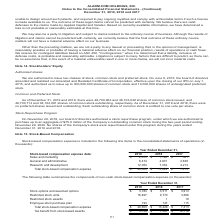According to Alarmcom Holdings's financial document, What was the value of restricted stock units in 2019?? According to the financial document, 16,627 (in thousands). The relevant text states: "ns $ 3,783 $ 3,511 $ 3,913 Restricted stock units 16,627 9,770 3,366 Restricted stock awards — 1 19 Employee stock purchase plan 193 147 115 Total stock-bas..." Also, What was the Stock options and assumed options in 2018? According to the financial document, 3,511 (in thousands). The relevant text states: "2017 Stock options and assumed options $ 3,783 $ 3,511 $ 3,913 Restricted stock units 16,627 9,770 3,366 Restricted stock awards — 1 19 Employee stock pur..." Also, Which years does the table provide information for  the components of non-cash stock-based compensation expense for? The document contains multiple relevant values: 2019, 2018, 2017. From the document: "Stock-based compensation expense data: 2019 2018 2017 Sales and marketing $ 2,075 $ 1,196 $ 561 General and administrative 6,474 4,901 2,638 Research ..." Also, How many years did Stock options and assumed options exceed $3,000 thousand? Counting the relevant items in the document: 2019, 2018, 2017, I find 3 instances. The key data points involved are: 2017, 2018, 2019. Also, can you calculate: What was the change in the Employee stock purchase plan between 2018 and 2019? Based on the calculation: 193-147, the result is 46 (in thousands). This is based on the information: "stock awards — 1 19 Employee stock purchase plan 193 147 115 Total stock-based compensation expense $ 20,603 $ 13,429 $ 7,413 Tax benefit from stock-bas ck awards — 1 19 Employee stock purchase plan 1..." The key data points involved are: 147, 193. Also, can you calculate: What was the percentage change in the Total stock-based compensation expense between 2018 and 2019? To answer this question, I need to perform calculations using the financial data. The calculation is: (20,603-13,429)/13,429, which equals 53.42 (percentage). This is based on the information: "Total stock-based compensation expense $ 20,603 $ 13,429 $ 7,413 32 4,214 Total stock-based compensation expense $ 20,603 $ 13,429 $ 7,413..." The key data points involved are: 13,429, 20,603. 